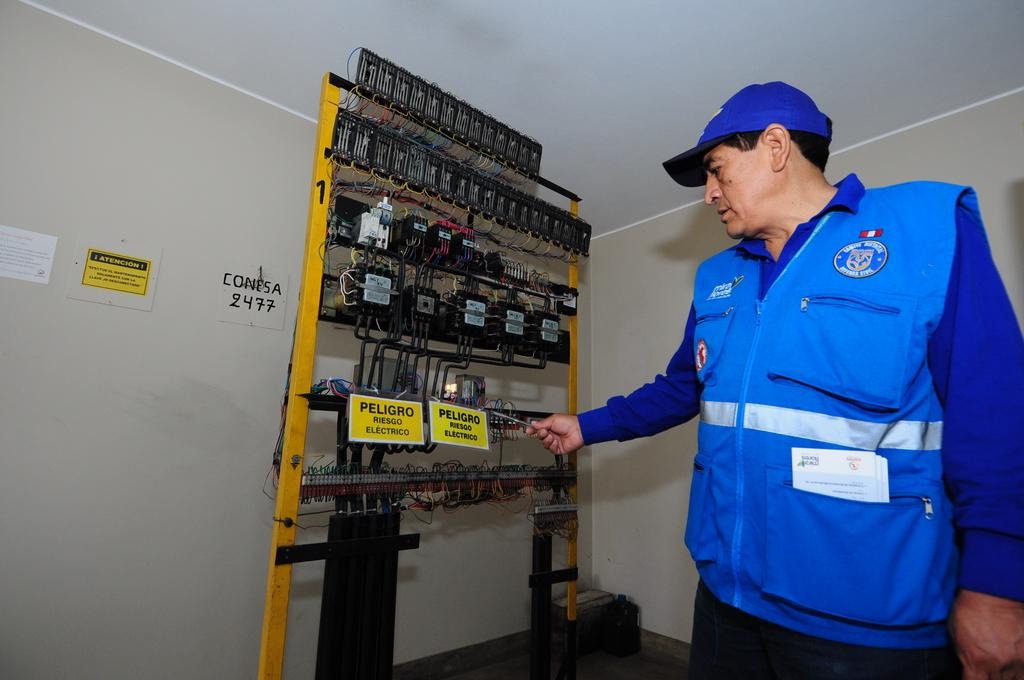Who is present in the image? There is a man in the image. Where is the man located in the image? The man is standing on the right side of the image. What object is in the center of the image? There is an electric stand in the image. What type of animal is playing chess with the man in the image? There is no animal or chess game present in the image. 